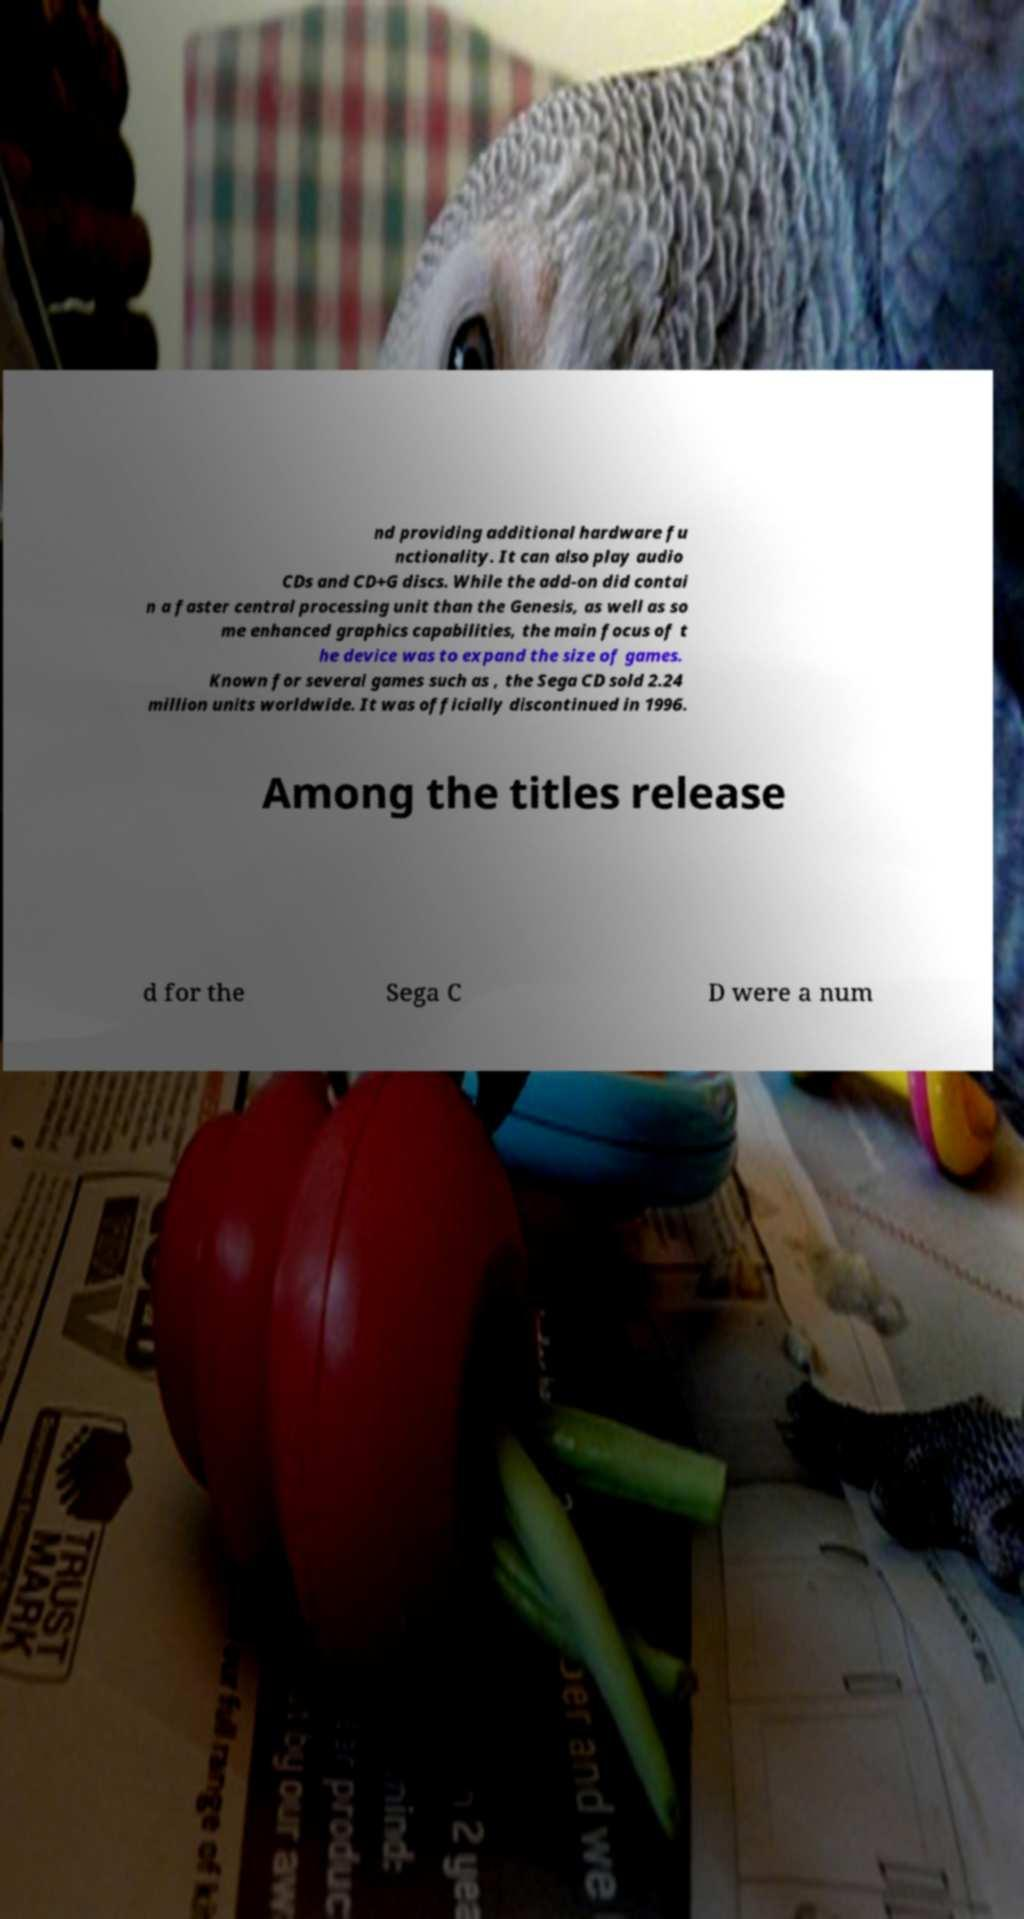What messages or text are displayed in this image? I need them in a readable, typed format. nd providing additional hardware fu nctionality. It can also play audio CDs and CD+G discs. While the add-on did contai n a faster central processing unit than the Genesis, as well as so me enhanced graphics capabilities, the main focus of t he device was to expand the size of games. Known for several games such as , the Sega CD sold 2.24 million units worldwide. It was officially discontinued in 1996. Among the titles release d for the Sega C D were a num 